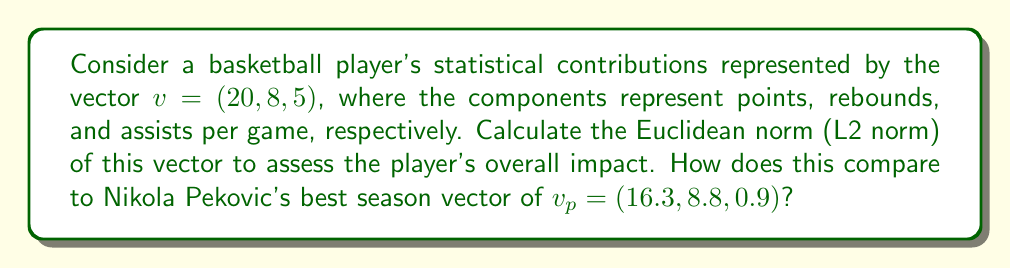Show me your answer to this math problem. To solve this problem, we'll follow these steps:

1) The Euclidean norm (L2 norm) of a vector $v = (v_1, v_2, ..., v_n)$ is defined as:

   $$\|v\|_2 = \sqrt{\sum_{i=1}^n |v_i|^2}$$

2) For our player's vector $v = (20, 8, 5)$:

   $$\|v\|_2 = \sqrt{20^2 + 8^2 + 5^2}$$

3) Let's calculate:
   
   $$\|v\|_2 = \sqrt{400 + 64 + 25} = \sqrt{489} \approx 22.11$$

4) Now, for Nikola Pekovic's vector $v_p = (16.3, 8.8, 0.9)$:

   $$\|v_p\|_2 = \sqrt{16.3^2 + 8.8^2 + 0.9^2}$$

5) Calculating:

   $$\|v_p\|_2 = \sqrt{265.69 + 77.44 + 0.81} = \sqrt{343.94} \approx 18.55$$

6) Comparing the two norms:
   
   Our player's norm (22.11) is higher than Pekovic's (18.55), indicating a potentially greater overall statistical impact. However, it's important to note that this simple norm calculation doesn't account for the relative importance of different statistical categories or other factors like efficiency and defensive contributions.
Answer: The Euclidean norm of the player's vector is approximately 22.11, which is higher than Nikola Pekovic's best season vector norm of approximately 18.55. 